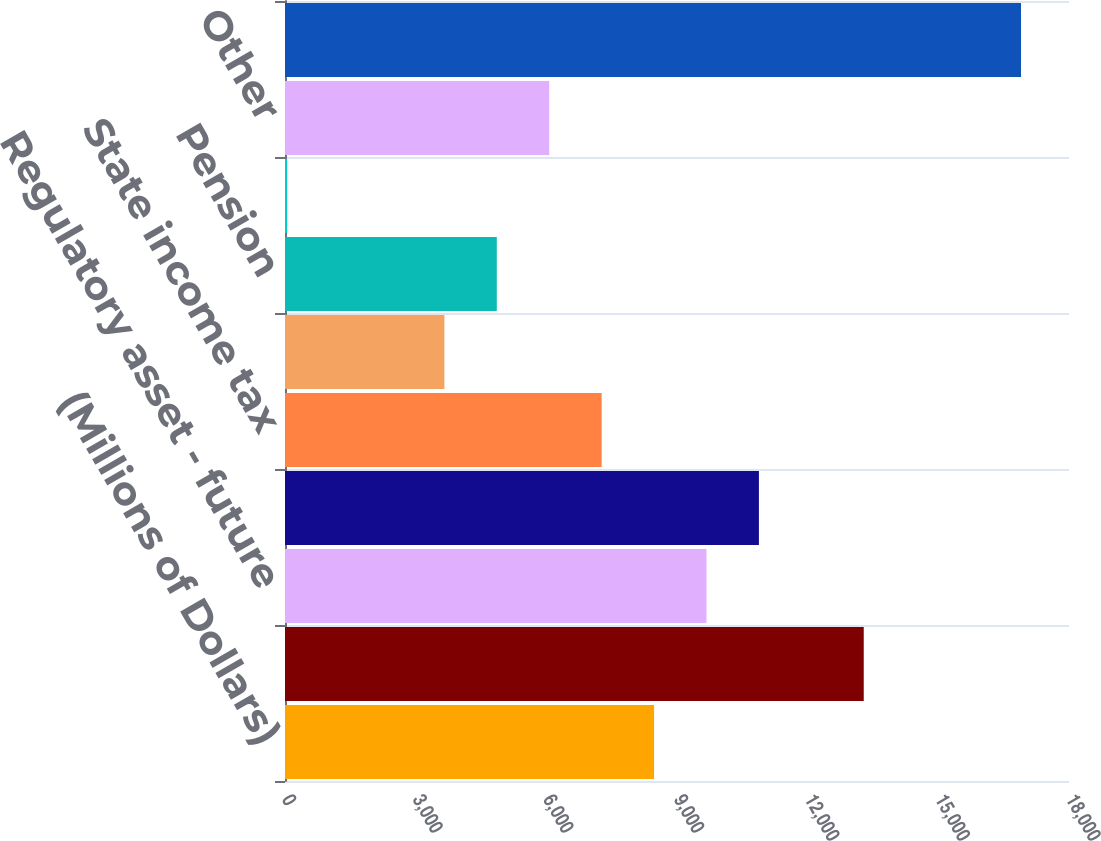Convert chart. <chart><loc_0><loc_0><loc_500><loc_500><bar_chart><fcel>(Millions of Dollars)<fcel>Depreciation<fcel>Regulatory asset - future<fcel>Unrecognized pension and other<fcel>State income tax<fcel>Capitalized overheads<fcel>Pension<fcel>Investment tax credits<fcel>Other<fcel>Total deferred tax liabilities<nl><fcel>8473.5<fcel>13287.5<fcel>9677<fcel>10880.5<fcel>7270<fcel>3659.5<fcel>4863<fcel>49<fcel>6066.5<fcel>16898<nl></chart> 